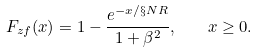<formula> <loc_0><loc_0><loc_500><loc_500>F _ { z f } ( x ) = 1 - \frac { e ^ { - x / \S N R } } { 1 + \beta ^ { 2 } } , \quad x \geq 0 .</formula> 